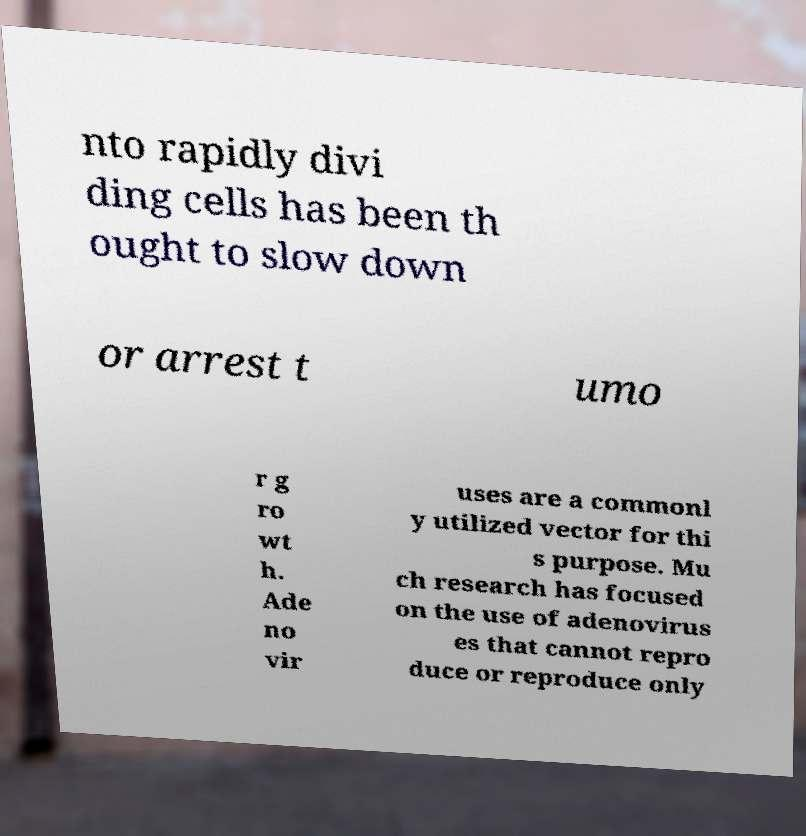Can you read and provide the text displayed in the image?This photo seems to have some interesting text. Can you extract and type it out for me? nto rapidly divi ding cells has been th ought to slow down or arrest t umo r g ro wt h. Ade no vir uses are a commonl y utilized vector for thi s purpose. Mu ch research has focused on the use of adenovirus es that cannot repro duce or reproduce only 